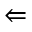<formula> <loc_0><loc_0><loc_500><loc_500>\Leftarrow</formula> 